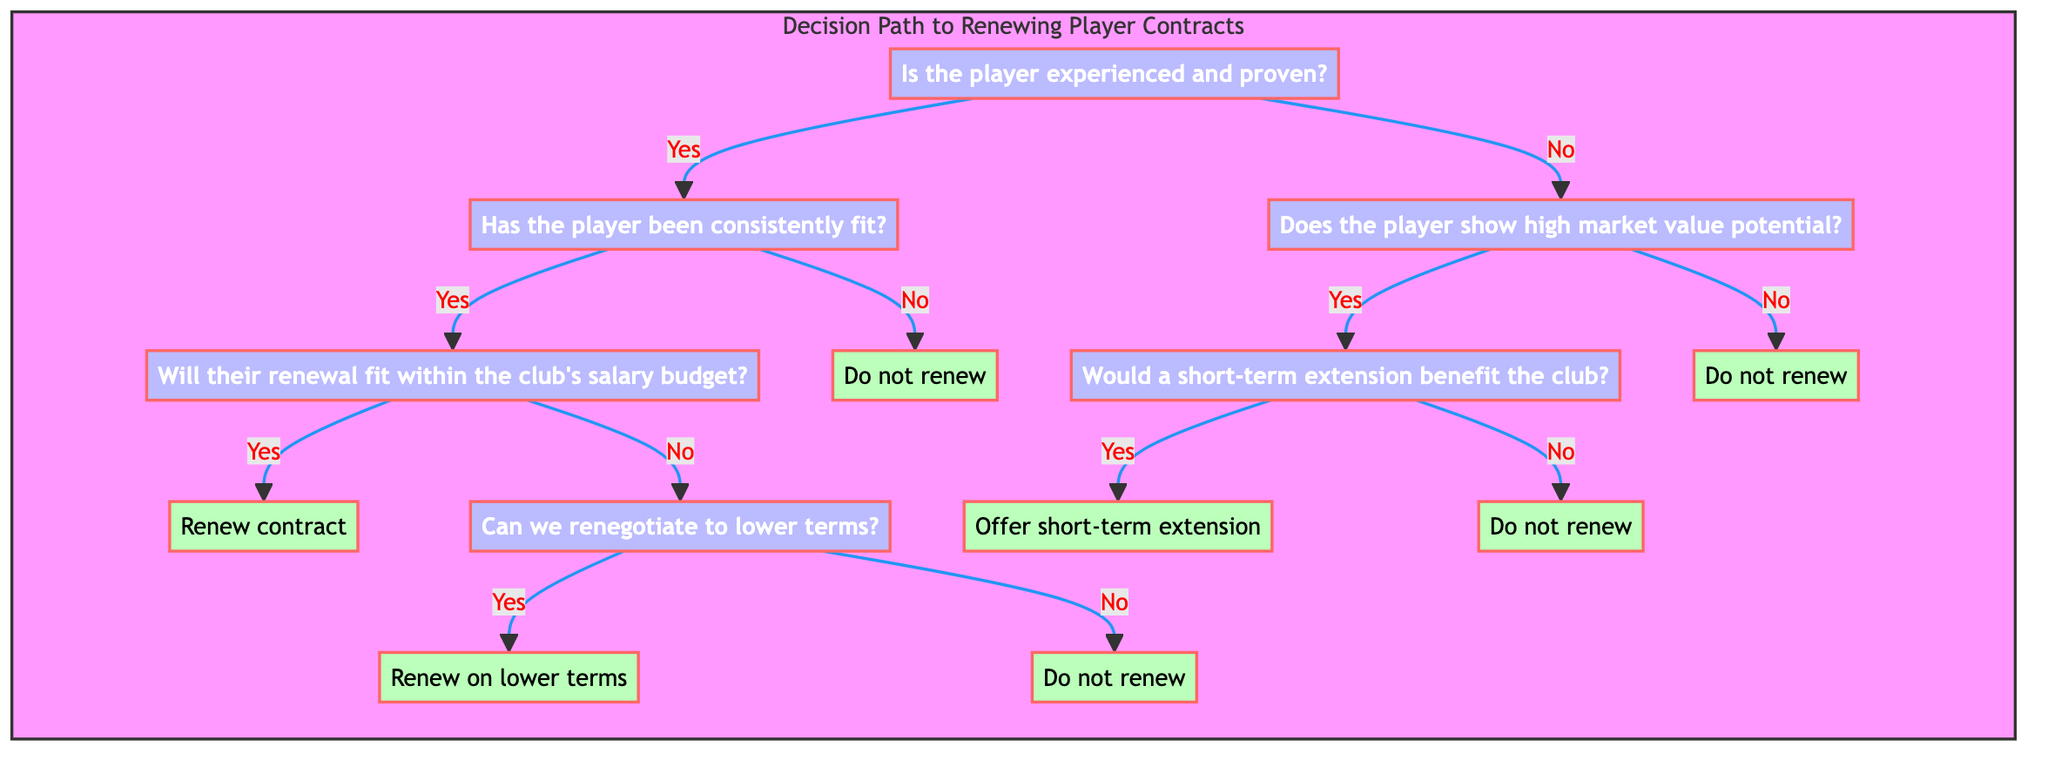Is the player's experience the first step in this decision tree? The first decision point in the tree is whether the player is experienced and proven, indicating that experience is indeed the primary factor considered.
Answer: Yes How many major decision nodes are there in the diagram? The diagram consists of four major decision nodes: experienced and proven, consistently fit, high market value potential, and would a short-term extension benefit the club.
Answer: Four What action is taken if the player has been consistently fit and their renewal fits within the club's salary budget? If both conditions are met, the action taken is to renew the contract while evaluating performance each season, indicating a positive outcome for the player.
Answer: Renew contract What happens if the player is inexperienced and shows no high market value potential? In this scenario, the action is to not renew the contract, emphasizing that players must prove their worth before receiving high-value contracts.
Answer: Do not renew If a player is experienced but injury-prone, what is the decision? The decision in this case is to not renew the contract because injury-prone players represent a financial risk to the club.
Answer: Do not renew What should the club do if the renewal does not fit within the salary budget but negotiations for lower terms are possible? If it is feasible to renegotiate to lower terms, the club should renew the contract on those lower terms, possibly with a shorter duration or performance-based incentives.
Answer: Renew on lower terms In which scenario would the club consider offering a short-term extension for a player? A short-term extension is considered if the player shows high market value potential and a short-term extension is deemed beneficial for the club, allowing the player's abilities to be tested further.
Answer: Offer short-term extension What is the outcome if a player shows high market value potential but a short-term extension is not beneficial? If a short-term extension is not beneficial for the club, the action taken is to not renew the contract, reinforcing that potential alone is insufficient without proven performance.
Answer: Do not renew 